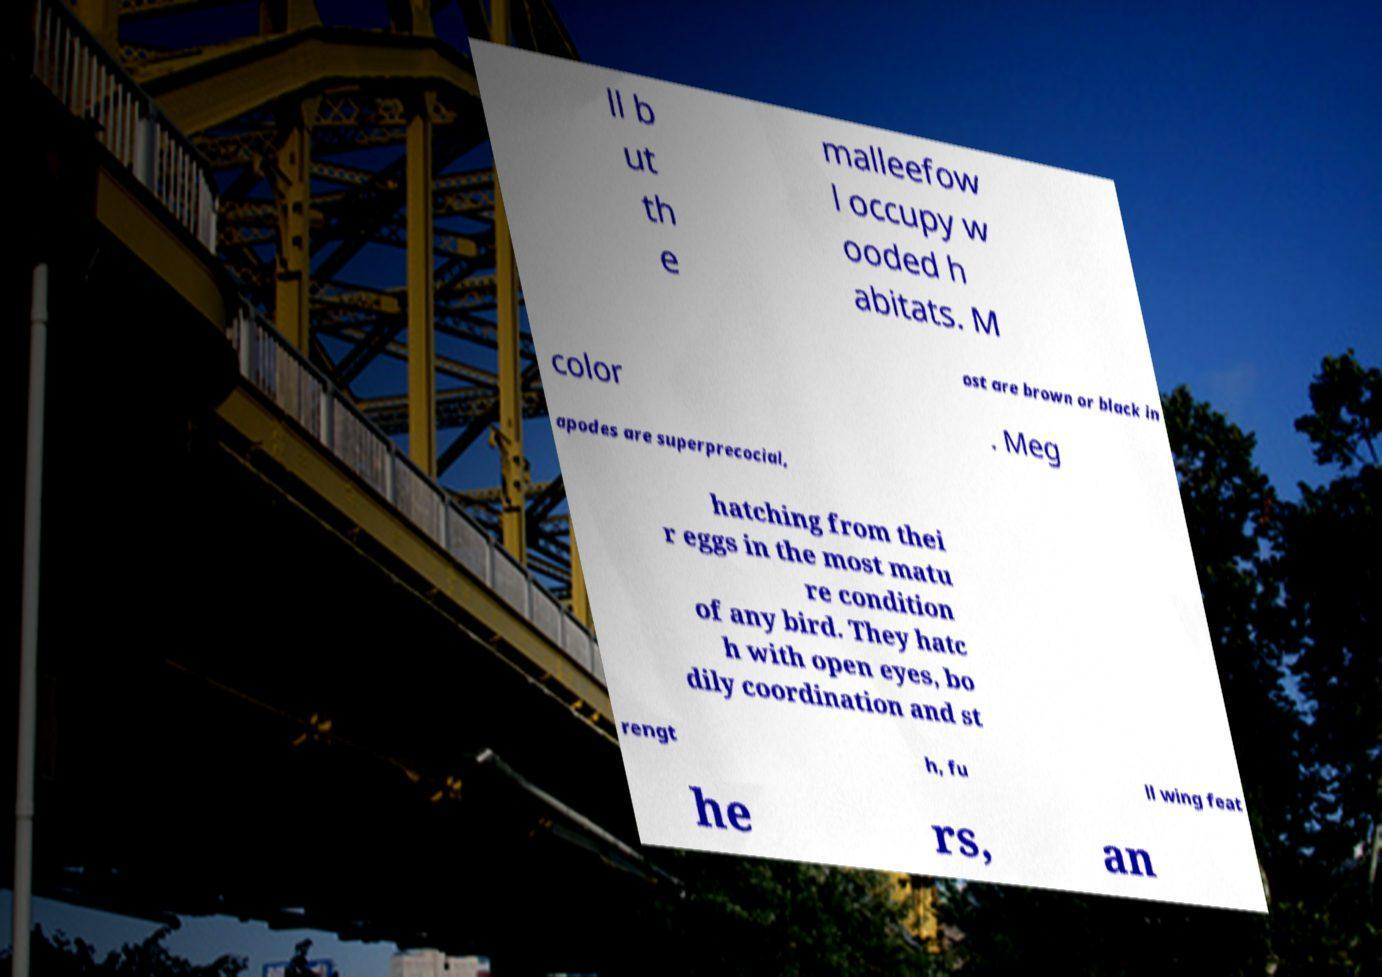Could you assist in decoding the text presented in this image and type it out clearly? ll b ut th e malleefow l occupy w ooded h abitats. M ost are brown or black in color . Meg apodes are superprecocial, hatching from thei r eggs in the most matu re condition of any bird. They hatc h with open eyes, bo dily coordination and st rengt h, fu ll wing feat he rs, an 